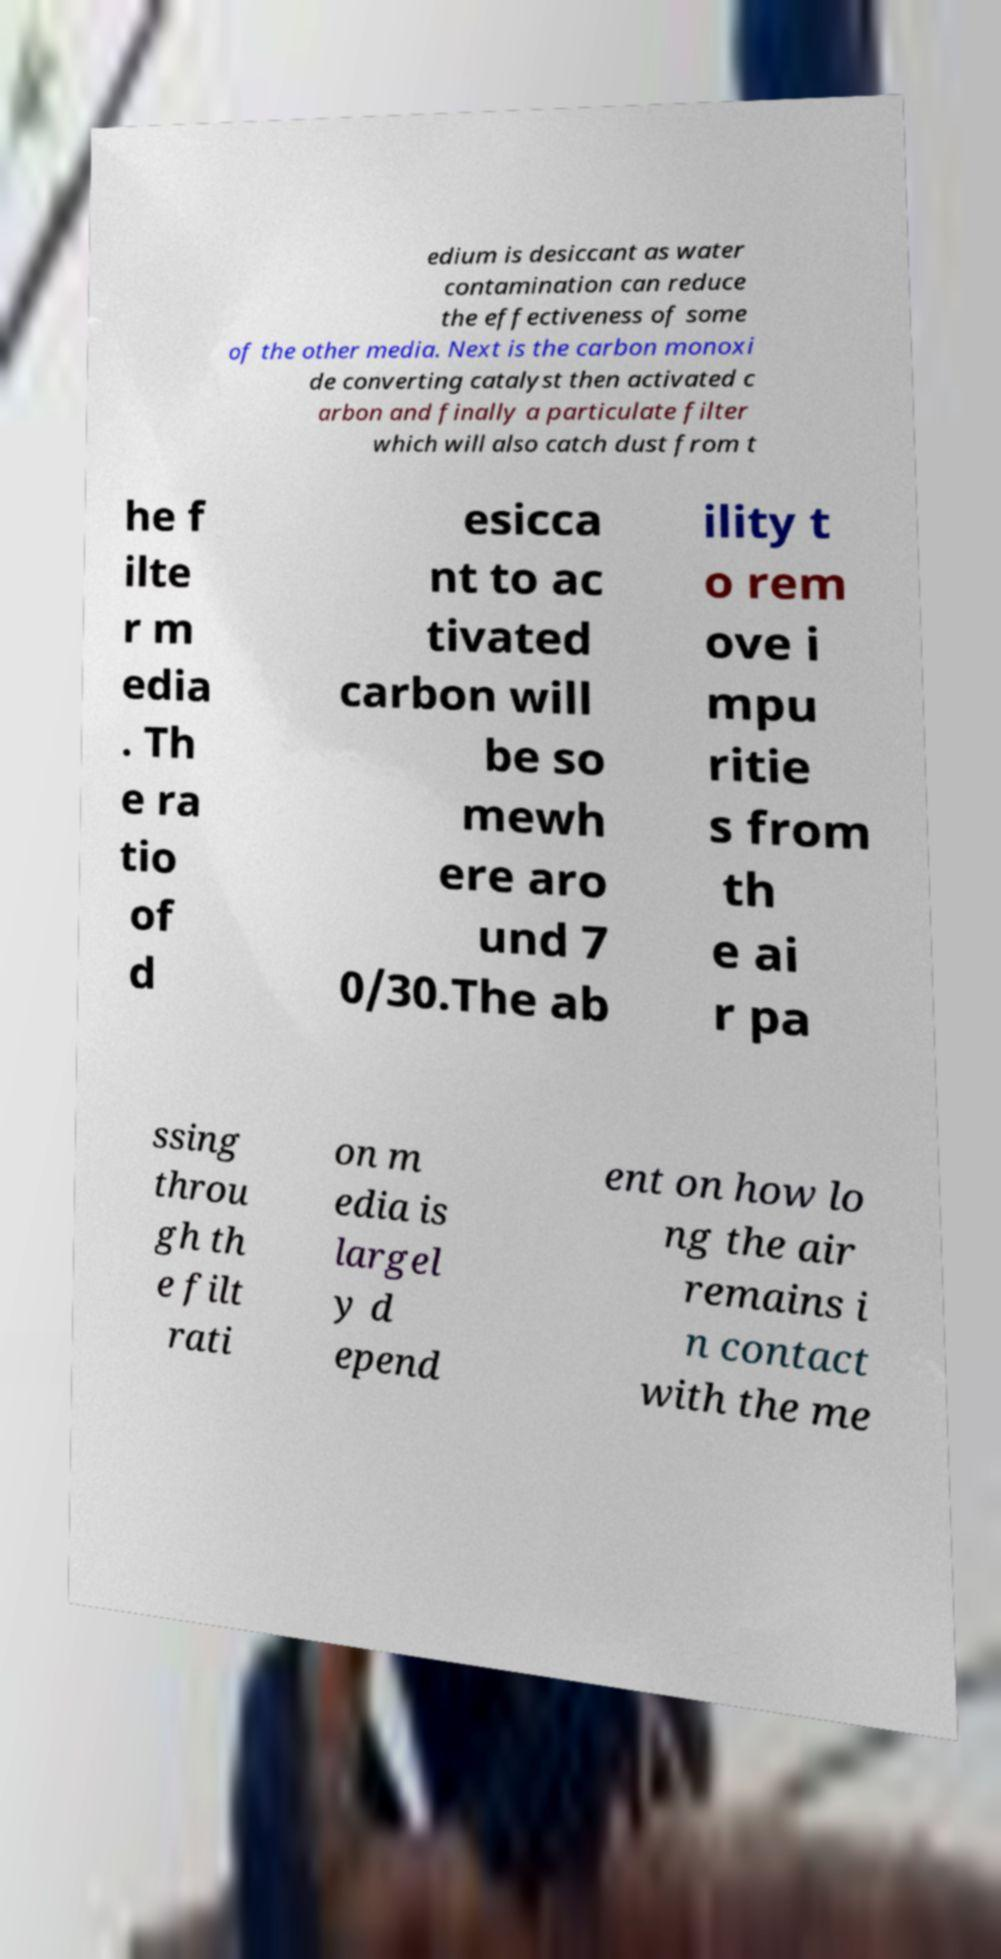Please identify and transcribe the text found in this image. edium is desiccant as water contamination can reduce the effectiveness of some of the other media. Next is the carbon monoxi de converting catalyst then activated c arbon and finally a particulate filter which will also catch dust from t he f ilte r m edia . Th e ra tio of d esicca nt to ac tivated carbon will be so mewh ere aro und 7 0/30.The ab ility t o rem ove i mpu ritie s from th e ai r pa ssing throu gh th e filt rati on m edia is largel y d epend ent on how lo ng the air remains i n contact with the me 